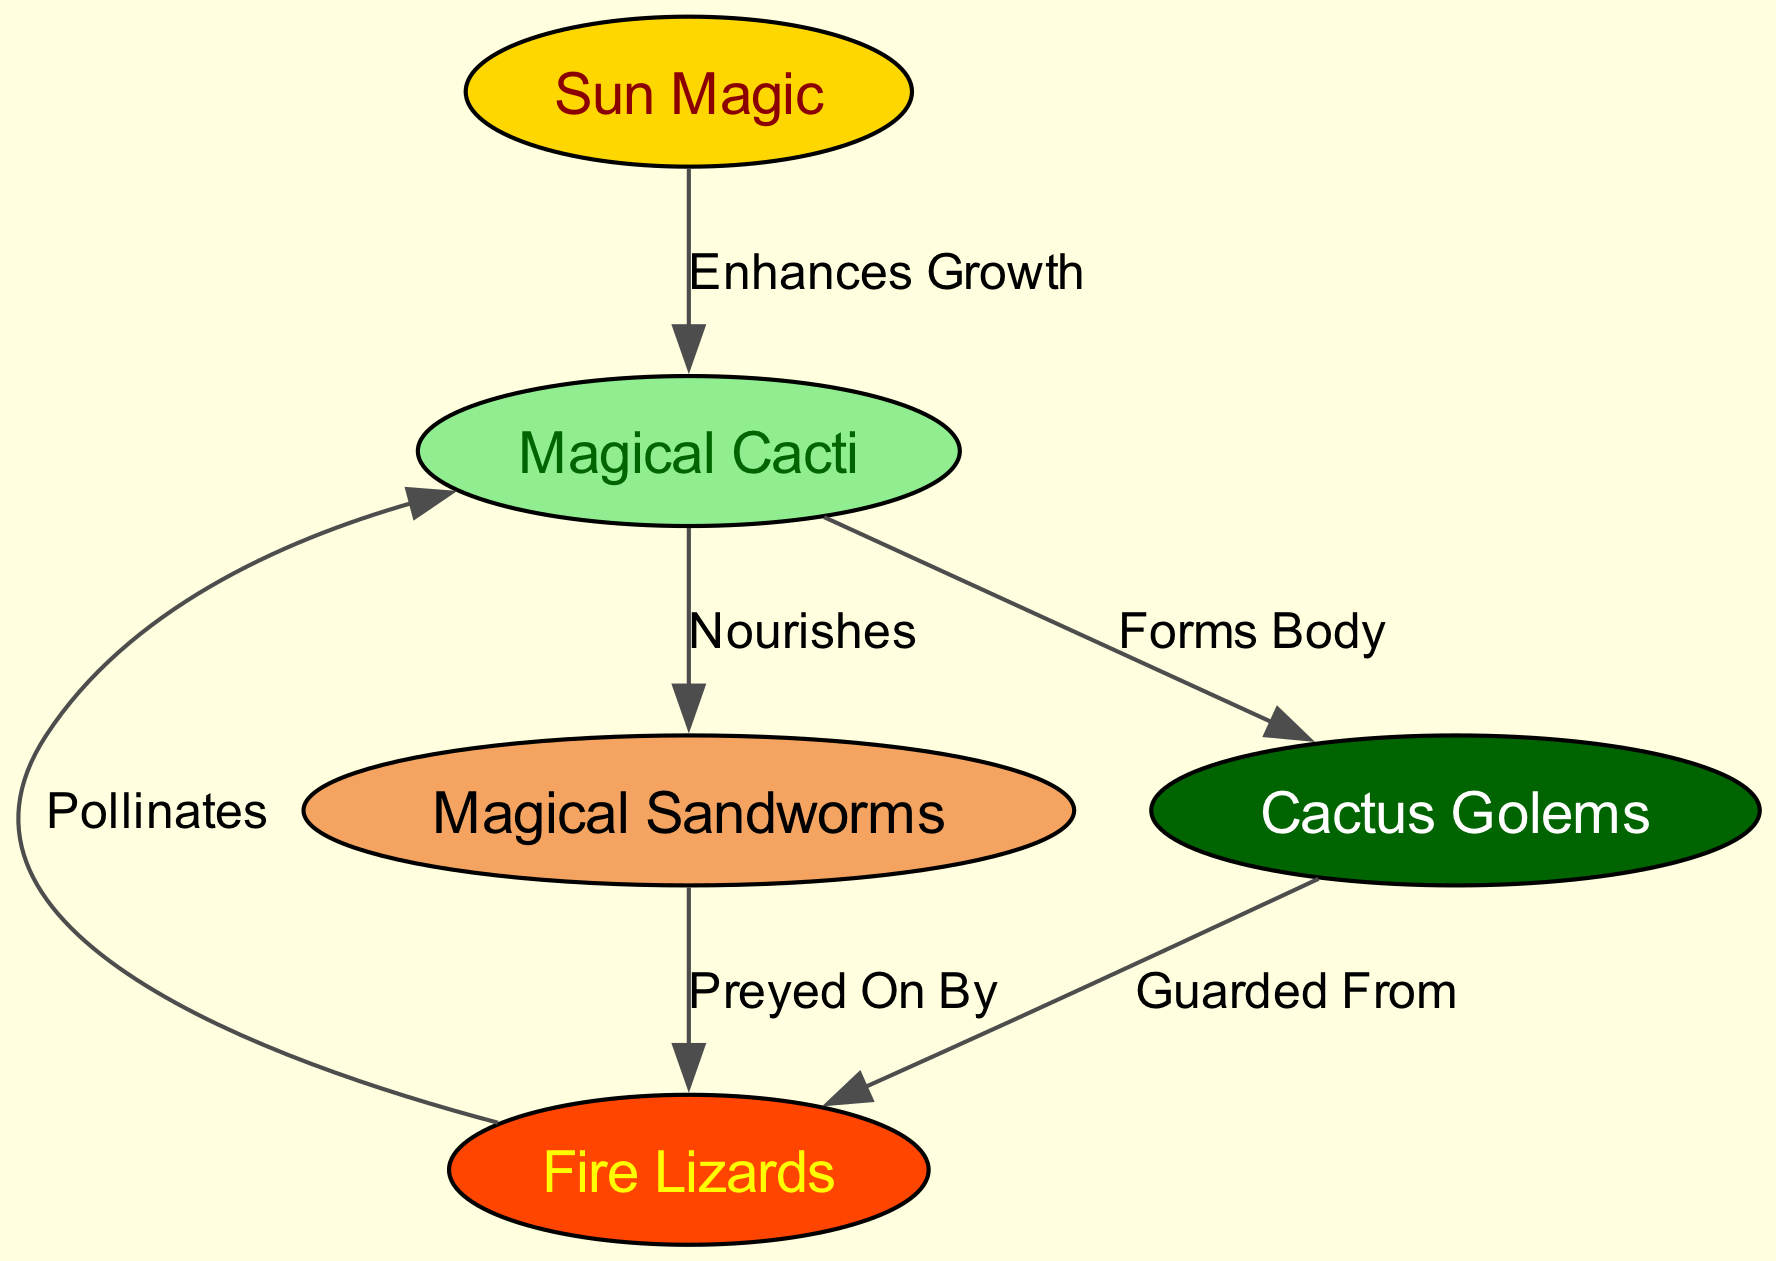What is the main source of energy for the ecosystem? The diagram indicates that "Sun Magic" is the primary energy source, as it is the top node and enhances the growth of "Magical Cacti."
Answer: Sun Magic How many nodes are present in the diagram? By counting the listed nodes, we find there are five distinct elements in the ecosystem—Sun Magic, Magical Sandworms, Fire Lizards, Magical Cacti, and Cactus Golems.
Answer: 5 What do the magical cacti provide nourishment to? The diagram shows that "Magical Cacti" nourish "Magical Sandworms," which directly connects them with an edge labeled "Nourishes."
Answer: Magical Sandworms Who is preying on the magical sandworms? The diagram specifies that "Fire Lizards" are preying on "Magical Sandworms," establishing a direct predator-prey relationship as indicated by the edge labeled "Preyed On By."
Answer: Fire Lizards Which creature does the sun magic enhance the growth of? The edge labeled "Enhances Growth" demonstrates that "Sun Magic" directly aids the growth of "Magical Cacti" in the ecosystem.
Answer: Magical Cacti How do fire lizards interact with magical cacti? The diagram shows that "Fire Lizards" not only prey on "Magical Sandworms," but they also interact with "Magical Cacti" by providing pollination, as denoted by the edge labeled "Pollinates."
Answer: Pollinates Which creature guards fire lizards from threats? According to the diagram, "Cactus Golems" protect or guard "Fire Lizards," which is depicted by the edge labeled "Guarded From."
Answer: Cactus Golems What is the relationship between magical cacti and cactus golems? The diagram indicates that "Magical Cacti" form the body of "Cactus Golems," establishing a structural and biological connection between the two entities as shown by the edge labeled "Forms Body."
Answer: Forms Body What kind of ecosystem does the diagram represent? Given the interconnected relationships involving magic, creatures, and plants, the ecosystem depicted can be classified as a mystical or magical desert ecosystem.
Answer: Magical desert ecosystem 